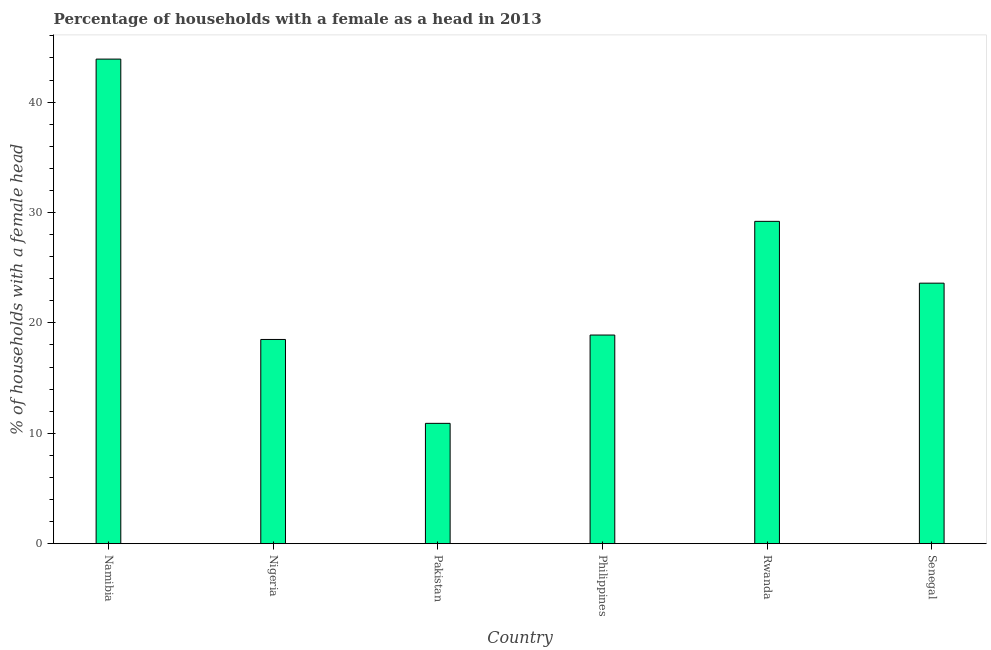What is the title of the graph?
Offer a very short reply. Percentage of households with a female as a head in 2013. What is the label or title of the X-axis?
Provide a short and direct response. Country. What is the label or title of the Y-axis?
Make the answer very short. % of households with a female head. What is the number of female supervised households in Namibia?
Offer a very short reply. 43.9. Across all countries, what is the maximum number of female supervised households?
Ensure brevity in your answer.  43.9. In which country was the number of female supervised households maximum?
Your response must be concise. Namibia. In which country was the number of female supervised households minimum?
Give a very brief answer. Pakistan. What is the sum of the number of female supervised households?
Keep it short and to the point. 145. What is the difference between the number of female supervised households in Namibia and Senegal?
Your answer should be compact. 20.3. What is the average number of female supervised households per country?
Provide a short and direct response. 24.17. What is the median number of female supervised households?
Make the answer very short. 21.25. In how many countries, is the number of female supervised households greater than 44 %?
Keep it short and to the point. 0. What is the ratio of the number of female supervised households in Namibia to that in Rwanda?
Give a very brief answer. 1.5. Is the difference between the number of female supervised households in Philippines and Senegal greater than the difference between any two countries?
Provide a short and direct response. No. What is the difference between the highest and the second highest number of female supervised households?
Give a very brief answer. 14.7. What is the difference between the highest and the lowest number of female supervised households?
Give a very brief answer. 33. Are all the bars in the graph horizontal?
Your answer should be very brief. No. How many countries are there in the graph?
Your answer should be very brief. 6. What is the difference between two consecutive major ticks on the Y-axis?
Ensure brevity in your answer.  10. What is the % of households with a female head of Namibia?
Provide a succinct answer. 43.9. What is the % of households with a female head in Pakistan?
Your answer should be compact. 10.9. What is the % of households with a female head of Philippines?
Make the answer very short. 18.9. What is the % of households with a female head of Rwanda?
Ensure brevity in your answer.  29.2. What is the % of households with a female head of Senegal?
Your answer should be very brief. 23.6. What is the difference between the % of households with a female head in Namibia and Nigeria?
Your answer should be compact. 25.4. What is the difference between the % of households with a female head in Namibia and Pakistan?
Your response must be concise. 33. What is the difference between the % of households with a female head in Namibia and Philippines?
Your response must be concise. 25. What is the difference between the % of households with a female head in Namibia and Rwanda?
Make the answer very short. 14.7. What is the difference between the % of households with a female head in Namibia and Senegal?
Provide a short and direct response. 20.3. What is the difference between the % of households with a female head in Nigeria and Pakistan?
Keep it short and to the point. 7.6. What is the difference between the % of households with a female head in Nigeria and Rwanda?
Provide a succinct answer. -10.7. What is the difference between the % of households with a female head in Nigeria and Senegal?
Your answer should be very brief. -5.1. What is the difference between the % of households with a female head in Pakistan and Rwanda?
Your answer should be very brief. -18.3. What is the difference between the % of households with a female head in Pakistan and Senegal?
Keep it short and to the point. -12.7. What is the difference between the % of households with a female head in Philippines and Rwanda?
Ensure brevity in your answer.  -10.3. What is the difference between the % of households with a female head in Rwanda and Senegal?
Provide a short and direct response. 5.6. What is the ratio of the % of households with a female head in Namibia to that in Nigeria?
Give a very brief answer. 2.37. What is the ratio of the % of households with a female head in Namibia to that in Pakistan?
Ensure brevity in your answer.  4.03. What is the ratio of the % of households with a female head in Namibia to that in Philippines?
Give a very brief answer. 2.32. What is the ratio of the % of households with a female head in Namibia to that in Rwanda?
Offer a terse response. 1.5. What is the ratio of the % of households with a female head in Namibia to that in Senegal?
Your response must be concise. 1.86. What is the ratio of the % of households with a female head in Nigeria to that in Pakistan?
Offer a very short reply. 1.7. What is the ratio of the % of households with a female head in Nigeria to that in Philippines?
Your answer should be very brief. 0.98. What is the ratio of the % of households with a female head in Nigeria to that in Rwanda?
Your answer should be compact. 0.63. What is the ratio of the % of households with a female head in Nigeria to that in Senegal?
Keep it short and to the point. 0.78. What is the ratio of the % of households with a female head in Pakistan to that in Philippines?
Ensure brevity in your answer.  0.58. What is the ratio of the % of households with a female head in Pakistan to that in Rwanda?
Ensure brevity in your answer.  0.37. What is the ratio of the % of households with a female head in Pakistan to that in Senegal?
Give a very brief answer. 0.46. What is the ratio of the % of households with a female head in Philippines to that in Rwanda?
Give a very brief answer. 0.65. What is the ratio of the % of households with a female head in Philippines to that in Senegal?
Your response must be concise. 0.8. What is the ratio of the % of households with a female head in Rwanda to that in Senegal?
Ensure brevity in your answer.  1.24. 